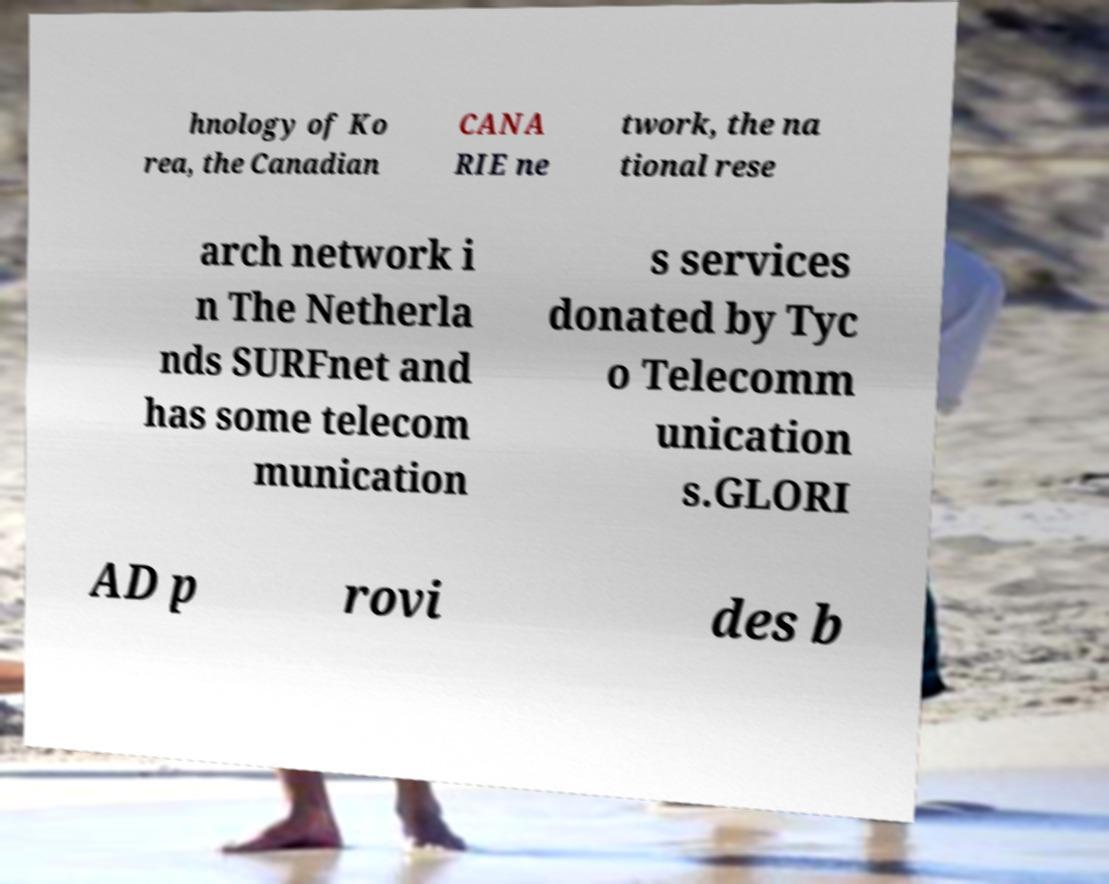Please identify and transcribe the text found in this image. hnology of Ko rea, the Canadian CANA RIE ne twork, the na tional rese arch network i n The Netherla nds SURFnet and has some telecom munication s services donated by Tyc o Telecomm unication s.GLORI AD p rovi des b 